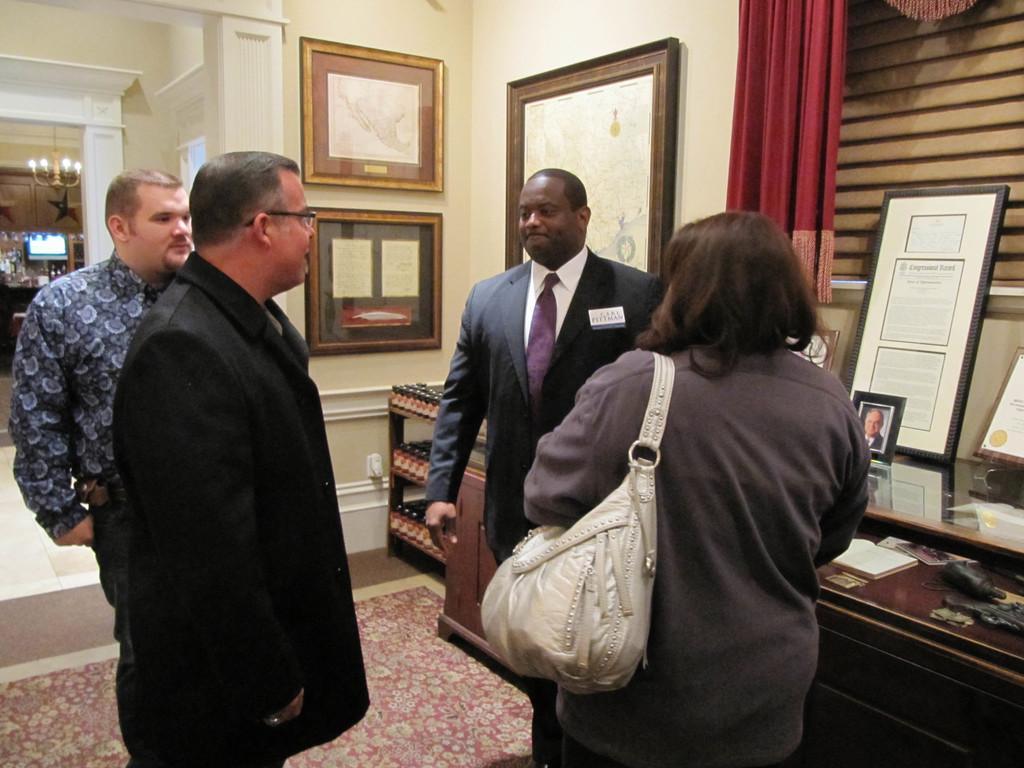Please provide a concise description of this image. Here there are three men and a woman carrying bag on her shoulder are standing on the floor. In the background there are frames on the wall,chandelier hanging to the roof top,curtain,photo frame and frames on a table and we can also see some other items. 